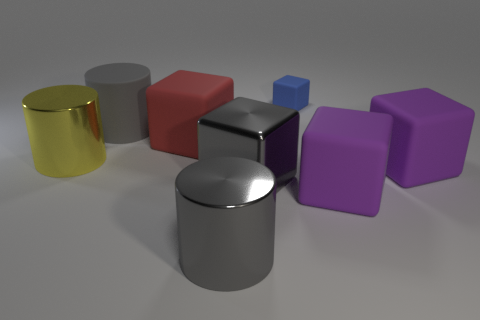What is the shape of the yellow thing?
Provide a succinct answer. Cylinder. Are there more matte blocks that are to the left of the red object than large yellow objects in front of the tiny blue rubber object?
Keep it short and to the point. No. There is a big thing to the left of the big gray matte cylinder; is its shape the same as the big thing behind the big red matte cube?
Your answer should be compact. Yes. How many other objects are there of the same size as the gray metal cube?
Make the answer very short. 6. The yellow metal cylinder has what size?
Ensure brevity in your answer.  Large. Does the large gray cylinder behind the yellow shiny cylinder have the same material as the large red block?
Ensure brevity in your answer.  Yes. The other tiny rubber object that is the same shape as the red object is what color?
Offer a terse response. Blue. There is a large cylinder that is in front of the big yellow metallic cylinder; is it the same color as the large metallic cube?
Provide a short and direct response. Yes. There is a large gray rubber object; are there any gray metal objects left of it?
Offer a terse response. No. The large thing that is to the left of the red thing and in front of the gray rubber cylinder is what color?
Your response must be concise. Yellow. 